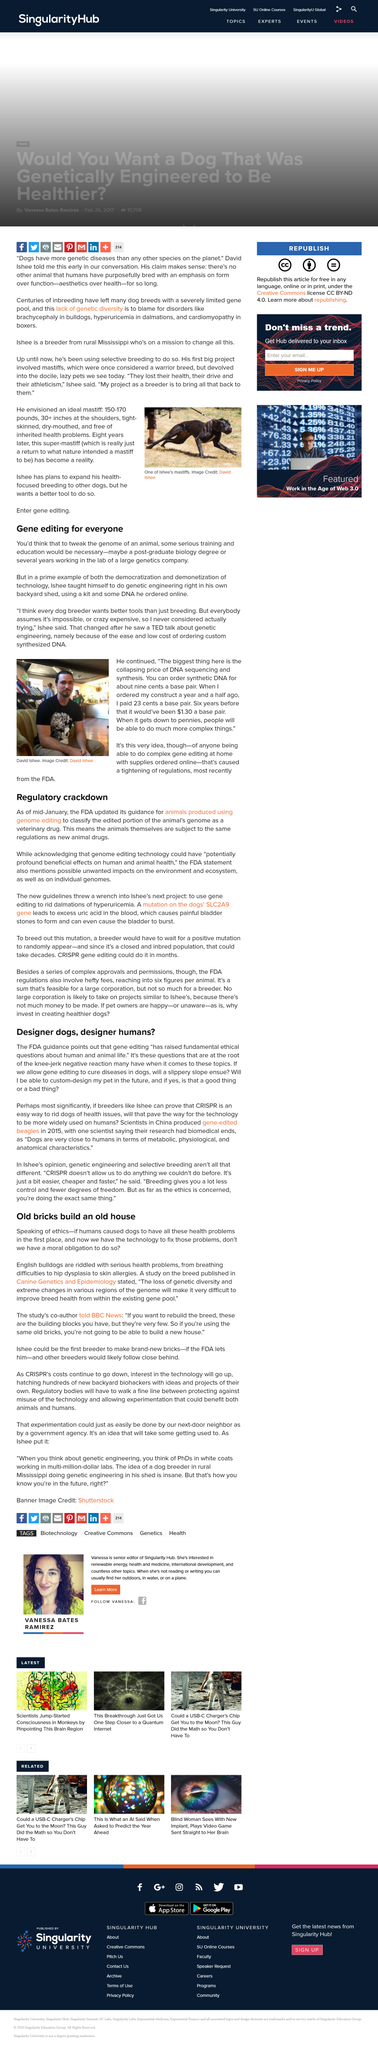Outline some significant characteristics in this image. Designer dogs, also known as "mutts" or "hybrids," can lead to a slippery slope, as they may be the first step in a process that could eventually lead to the creation of custom-designed dogs, and potentially even the gene editing of humans. This article discusses the health issues that dogs may experience. The FDA's new guidance for animals produced through genome editing applies to Dr. Ishee's next project, specifically addressing the mutation on the dogs' SLC2A9 gene. Inbreeding, defined as the mating of individuals who are related, can lead to generations of dogs with a limited gene pool, resulting in a plethora of health problems and genetic mutations. The title of the article is "Old Bricks Build and Old House," which provides insight into the historical significance of houses constructed using old bricks. 